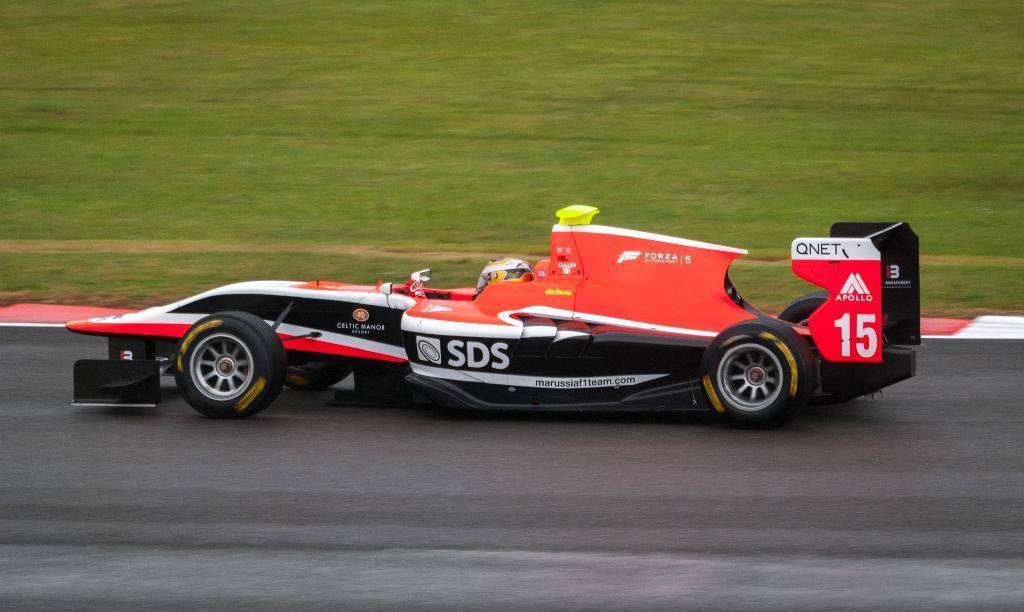Could you give a brief overview of what you see in this image? In this image we can see a car on the road. At the top of the image, we can see grassy land. We can see a person in the car. 